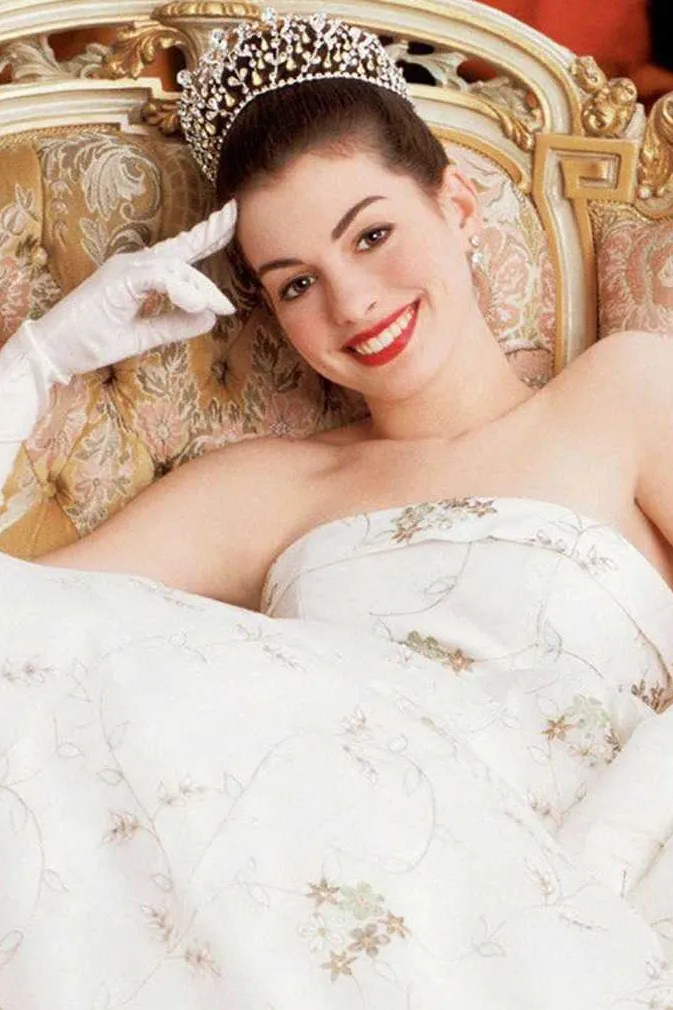What details in the decor might suggest a royal setting or a high society theme? The royal or high society theme is indicated by several elements within the decor. The sofa is ornately carved with gold accents that reflect opulence typical of regal environments. Additionally, the heavy, embroidered cushions and the intricate patterns on the walls further suggest a setting that is meant to signify wealth and status, typical of a palace or an aristocratic residence. 